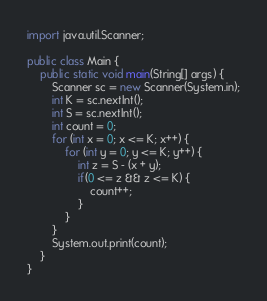Convert code to text. <code><loc_0><loc_0><loc_500><loc_500><_Java_>import java.util.Scanner;

public class Main {
	public static void main(String[] args) {
		Scanner sc = new Scanner(System.in);
		int K = sc.nextInt();
		int S = sc.nextInt();
		int count = 0;
		for (int x = 0; x <= K; x++) {
			for (int y = 0; y <= K; y++) {
				int z = S - (x + y);
				if(0 <= z && z <= K) {
					count++;
				}
			}
		}
		System.out.print(count);		
	}
}
</code> 